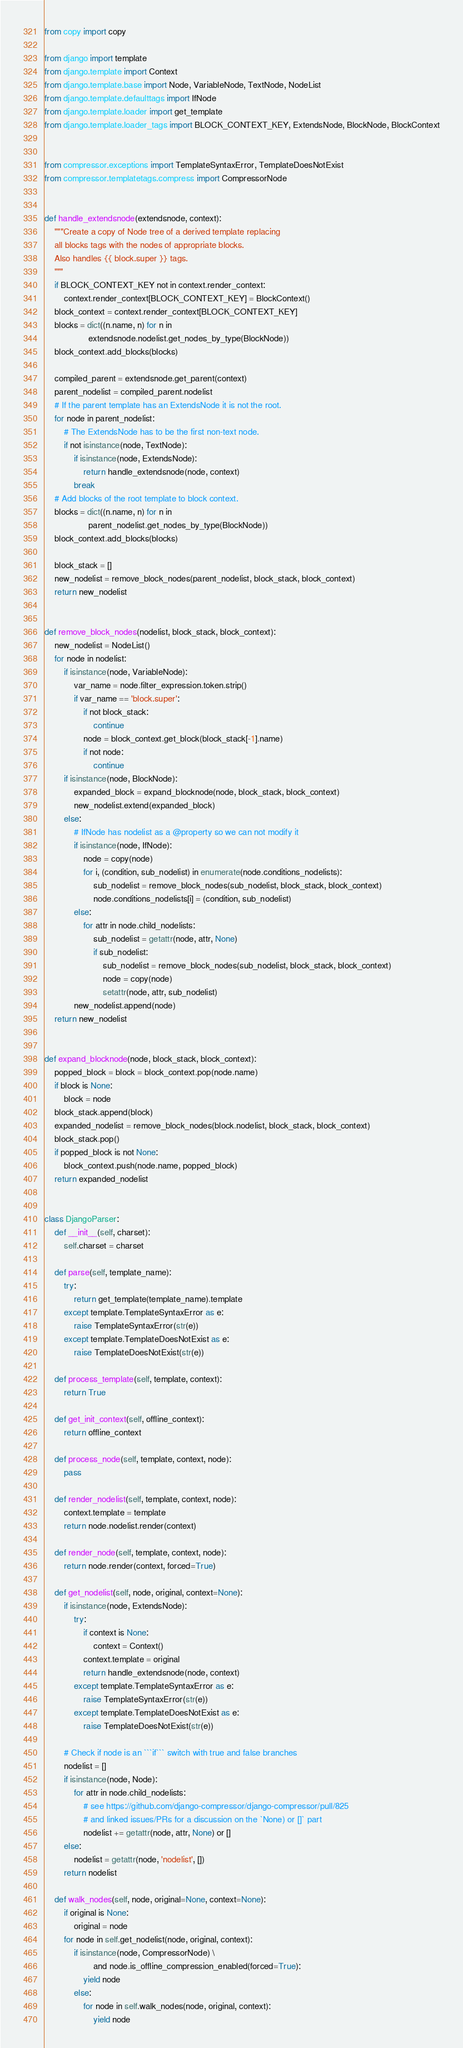<code> <loc_0><loc_0><loc_500><loc_500><_Python_>from copy import copy

from django import template
from django.template import Context
from django.template.base import Node, VariableNode, TextNode, NodeList
from django.template.defaulttags import IfNode
from django.template.loader import get_template
from django.template.loader_tags import BLOCK_CONTEXT_KEY, ExtendsNode, BlockNode, BlockContext


from compressor.exceptions import TemplateSyntaxError, TemplateDoesNotExist
from compressor.templatetags.compress import CompressorNode


def handle_extendsnode(extendsnode, context):
    """Create a copy of Node tree of a derived template replacing
    all blocks tags with the nodes of appropriate blocks.
    Also handles {{ block.super }} tags.
    """
    if BLOCK_CONTEXT_KEY not in context.render_context:
        context.render_context[BLOCK_CONTEXT_KEY] = BlockContext()
    block_context = context.render_context[BLOCK_CONTEXT_KEY]
    blocks = dict((n.name, n) for n in
                  extendsnode.nodelist.get_nodes_by_type(BlockNode))
    block_context.add_blocks(blocks)

    compiled_parent = extendsnode.get_parent(context)
    parent_nodelist = compiled_parent.nodelist
    # If the parent template has an ExtendsNode it is not the root.
    for node in parent_nodelist:
        # The ExtendsNode has to be the first non-text node.
        if not isinstance(node, TextNode):
            if isinstance(node, ExtendsNode):
                return handle_extendsnode(node, context)
            break
    # Add blocks of the root template to block context.
    blocks = dict((n.name, n) for n in
                  parent_nodelist.get_nodes_by_type(BlockNode))
    block_context.add_blocks(blocks)

    block_stack = []
    new_nodelist = remove_block_nodes(parent_nodelist, block_stack, block_context)
    return new_nodelist


def remove_block_nodes(nodelist, block_stack, block_context):
    new_nodelist = NodeList()
    for node in nodelist:
        if isinstance(node, VariableNode):
            var_name = node.filter_expression.token.strip()
            if var_name == 'block.super':
                if not block_stack:
                    continue
                node = block_context.get_block(block_stack[-1].name)
                if not node:
                    continue
        if isinstance(node, BlockNode):
            expanded_block = expand_blocknode(node, block_stack, block_context)
            new_nodelist.extend(expanded_block)
        else:
            # IfNode has nodelist as a @property so we can not modify it
            if isinstance(node, IfNode):
                node = copy(node)
                for i, (condition, sub_nodelist) in enumerate(node.conditions_nodelists):
                    sub_nodelist = remove_block_nodes(sub_nodelist, block_stack, block_context)
                    node.conditions_nodelists[i] = (condition, sub_nodelist)
            else:
                for attr in node.child_nodelists:
                    sub_nodelist = getattr(node, attr, None)
                    if sub_nodelist:
                        sub_nodelist = remove_block_nodes(sub_nodelist, block_stack, block_context)
                        node = copy(node)
                        setattr(node, attr, sub_nodelist)
            new_nodelist.append(node)
    return new_nodelist


def expand_blocknode(node, block_stack, block_context):
    popped_block = block = block_context.pop(node.name)
    if block is None:
        block = node
    block_stack.append(block)
    expanded_nodelist = remove_block_nodes(block.nodelist, block_stack, block_context)
    block_stack.pop()
    if popped_block is not None:
        block_context.push(node.name, popped_block)
    return expanded_nodelist


class DjangoParser:
    def __init__(self, charset):
        self.charset = charset

    def parse(self, template_name):
        try:
            return get_template(template_name).template
        except template.TemplateSyntaxError as e:
            raise TemplateSyntaxError(str(e))
        except template.TemplateDoesNotExist as e:
            raise TemplateDoesNotExist(str(e))

    def process_template(self, template, context):
        return True

    def get_init_context(self, offline_context):
        return offline_context

    def process_node(self, template, context, node):
        pass

    def render_nodelist(self, template, context, node):
        context.template = template
        return node.nodelist.render(context)

    def render_node(self, template, context, node):
        return node.render(context, forced=True)

    def get_nodelist(self, node, original, context=None):
        if isinstance(node, ExtendsNode):
            try:
                if context is None:
                    context = Context()
                context.template = original
                return handle_extendsnode(node, context)
            except template.TemplateSyntaxError as e:
                raise TemplateSyntaxError(str(e))
            except template.TemplateDoesNotExist as e:
                raise TemplateDoesNotExist(str(e))

        # Check if node is an ```if``` switch with true and false branches
        nodelist = []
        if isinstance(node, Node):
            for attr in node.child_nodelists:
                # see https://github.com/django-compressor/django-compressor/pull/825
                # and linked issues/PRs for a discussion on the `None) or []` part
                nodelist += getattr(node, attr, None) or []
        else:
            nodelist = getattr(node, 'nodelist', [])
        return nodelist

    def walk_nodes(self, node, original=None, context=None):
        if original is None:
            original = node
        for node in self.get_nodelist(node, original, context):
            if isinstance(node, CompressorNode) \
                    and node.is_offline_compression_enabled(forced=True):
                yield node
            else:
                for node in self.walk_nodes(node, original, context):
                    yield node
</code> 